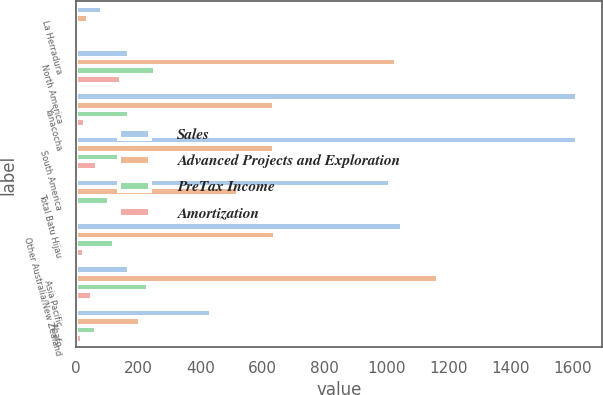Convert chart to OTSL. <chart><loc_0><loc_0><loc_500><loc_500><stacked_bar_chart><ecel><fcel>La Herradura<fcel>North America<fcel>Yanacocha<fcel>South America<fcel>Total Batu Hijau<fcel>Other Australia/New Zealand<fcel>Asia Pacific<fcel>Ahafo<nl><fcel>Sales<fcel>83<fcel>170<fcel>1613<fcel>1613<fcel>1013<fcel>1050<fcel>170<fcel>435<nl><fcel>Advanced Projects and Exploration<fcel>38<fcel>1031<fcel>637<fcel>637<fcel>523<fcel>642<fcel>1165<fcel>205<nl><fcel>PreTax Income<fcel>8<fcel>255<fcel>170<fcel>170<fcel>105<fcel>122<fcel>230<fcel>63<nl><fcel>Amortization<fcel>6<fcel>144<fcel>28<fcel>66<fcel>2<fcel>24<fcel>52<fcel>18<nl></chart> 